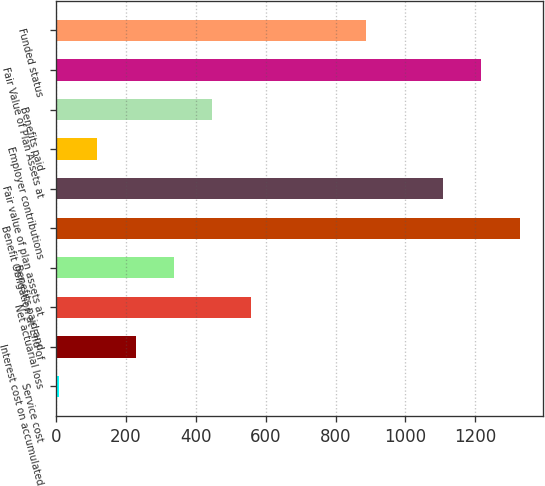<chart> <loc_0><loc_0><loc_500><loc_500><bar_chart><fcel>Service cost<fcel>Interest cost on accumulated<fcel>Net actuarial loss<fcel>Benefits paid and<fcel>Benefit Obligation at End of<fcel>Fair value of plan assets at<fcel>Employer contributions<fcel>Benefits paid<fcel>Fair Value of Plan Assets at<fcel>Funded status<nl><fcel>8<fcel>227.8<fcel>557.5<fcel>337.7<fcel>1326.8<fcel>1107<fcel>117.9<fcel>447.6<fcel>1216.9<fcel>887.2<nl></chart> 